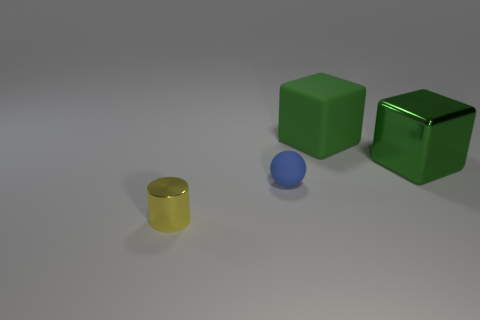Add 1 metallic cylinders. How many objects exist? 5 Subtract all cylinders. How many objects are left? 3 Subtract all small spheres. Subtract all big green metal things. How many objects are left? 2 Add 2 green metallic blocks. How many green metallic blocks are left? 3 Add 3 brown metal cubes. How many brown metal cubes exist? 3 Subtract 0 cyan blocks. How many objects are left? 4 